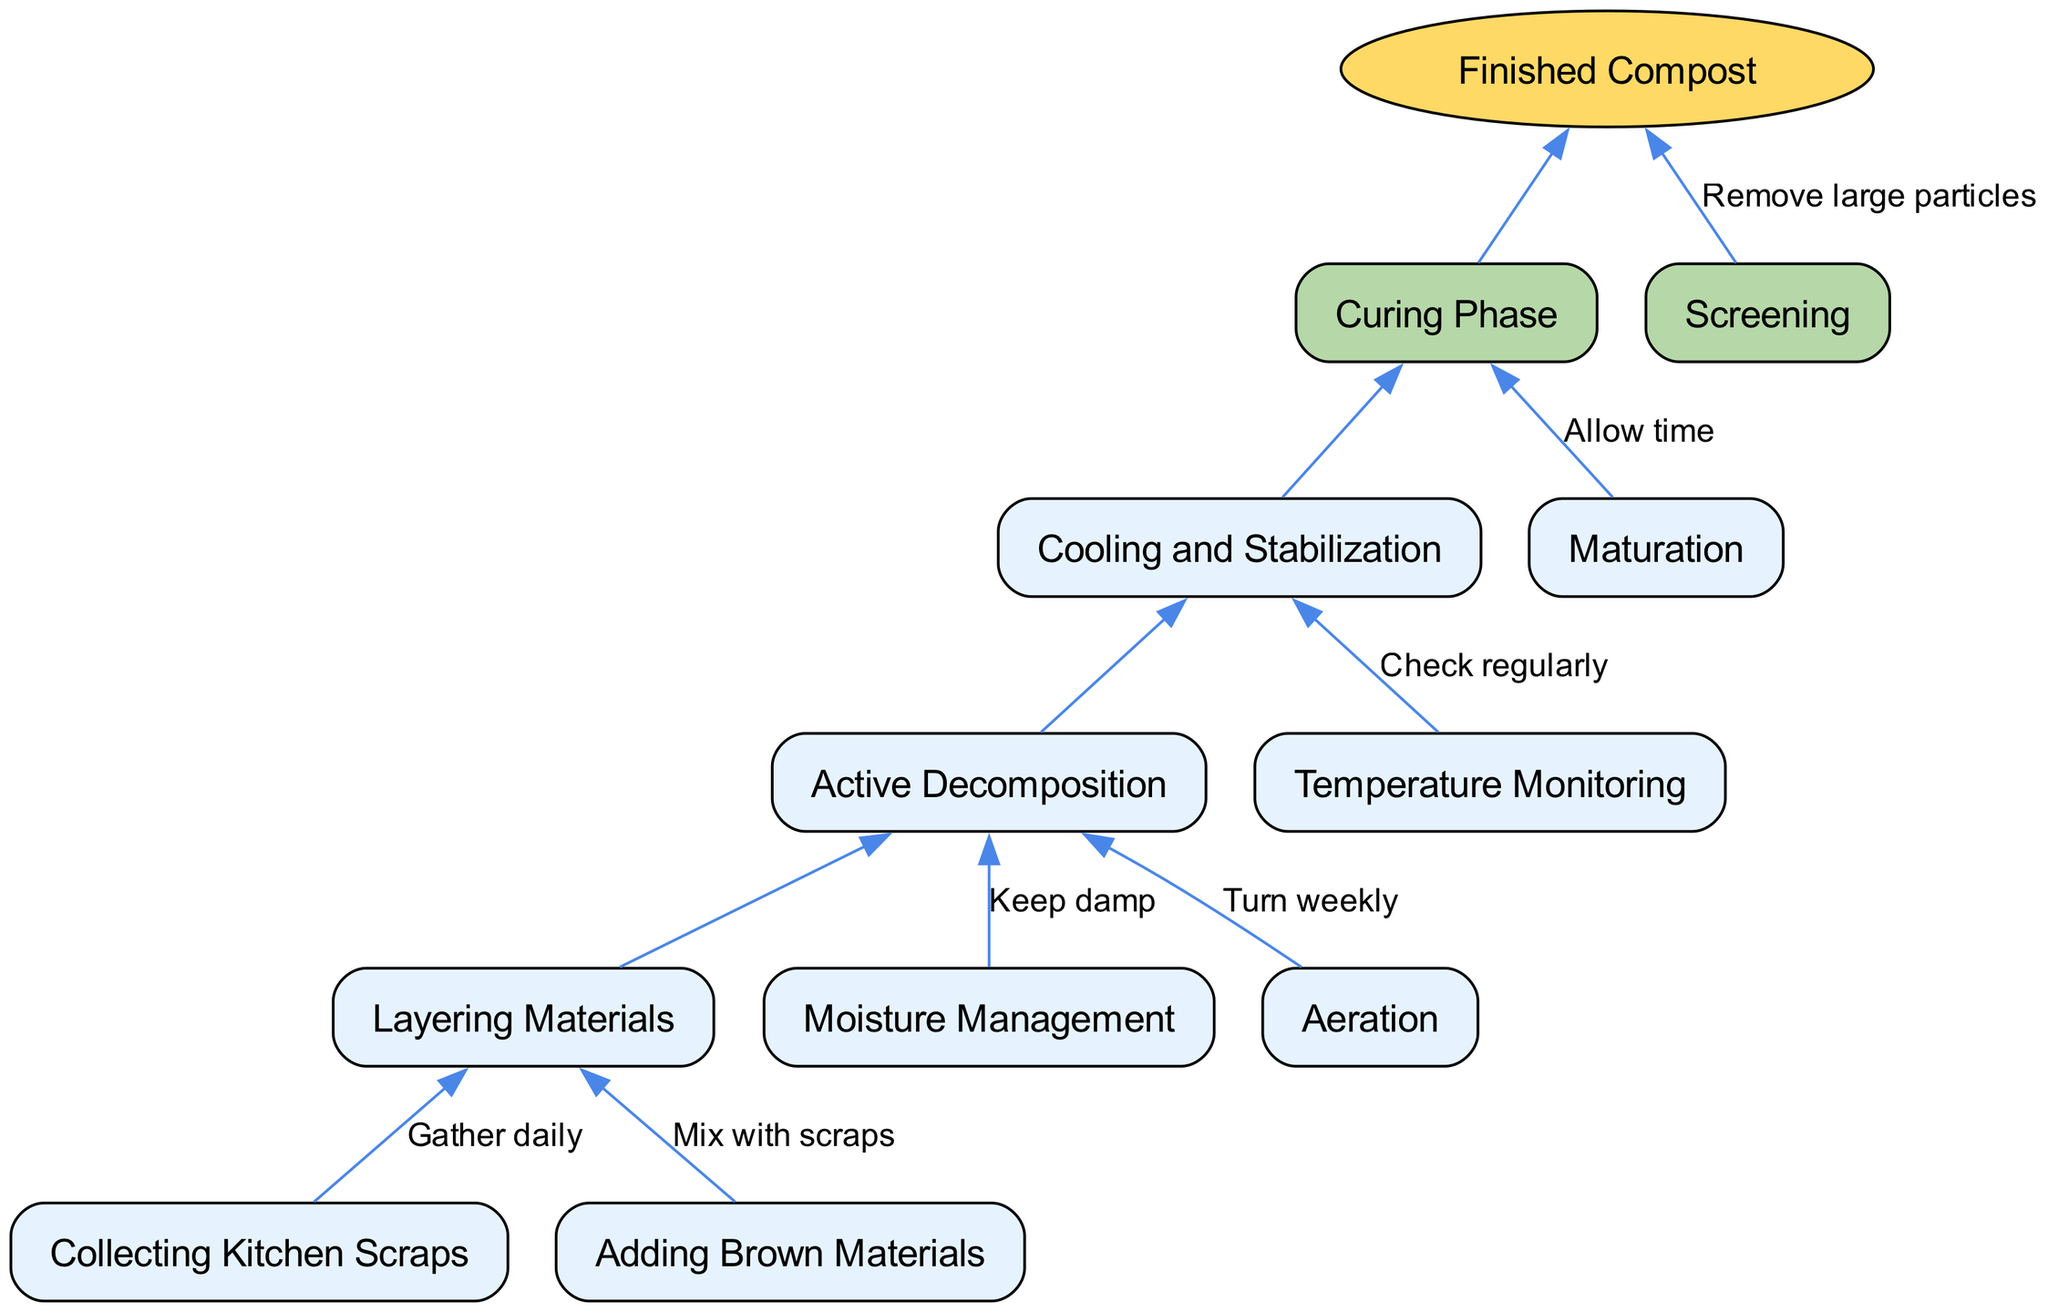What is the root node of the diagram? The root node is specified in the "root" key of the data. In this case, it states "Finished Compost" as the overall outcome of the composting process.
Answer: Finished Compost How many main branches are there in the diagram? The main branches are represented in the "branches" array of the data. There are two branches: "Curing Phase" and "Screening". Therefore, the count is 2.
Answer: 2 What is the edge label connecting "Curing Phase" to "Finished Compost"? The edge label for the branch connecting to the root is given as an empty string in the current diagram, indicating no specific action, just the connection itself.
Answer: (no label) Which phase comes after "Active Decomposition"? Following the structure of the diagram, "Active Decomposition" leads to "Cooling and Stabilization". This is found as a child of the "Curing Phase".
Answer: Cooling and Stabilization What is the final step before achieving finished compost? The last step according to the flow is the "Maturation" phase, which includes the edge label "Allow time" for allowing the materials to mature.
Answer: Maturation How should moisture be managed in the composting process? There is a specific instruction listed as "Keep damp" linked with the "Moisture Management" node, indicating the necessity for maintaining moisture levels during composting.
Answer: Keep damp What is the action required for "Aeration"? The action described for "Aeration" in the diagram states "Turn weekly", which advises on how to manage aeration in the composting process.
Answer: Turn weekly What happens during the "Curing Phase"? The "Curing Phase" conveys that cooling and stabilization first occur, following active decomposition, initially leading to better quality compost. This response summarizes the sequence involved effectively.
Answer: Cooling and Stabilization Which step involves collecting kitchen scraps? The process starts with the step named "Collecting Kitchen Scraps", where the instruction is labeled as "Gather daily", indicating the routine collection of materials.
Answer: Collecting Kitchen Scraps 